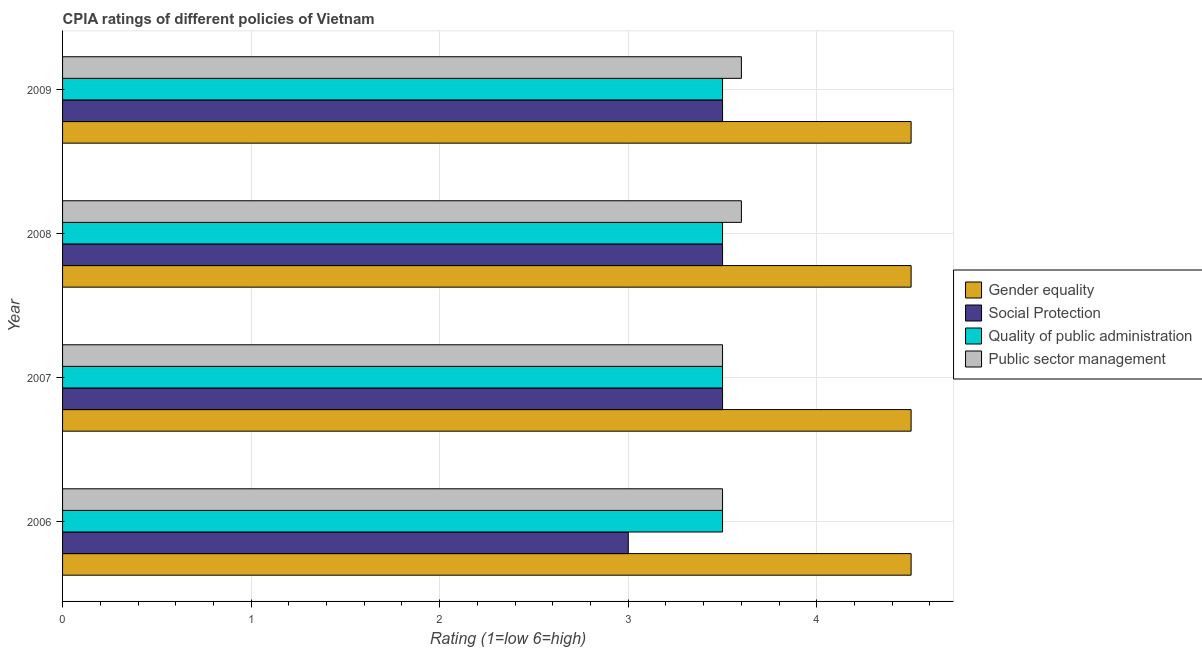Are the number of bars on each tick of the Y-axis equal?
Your answer should be very brief. Yes. How many bars are there on the 2nd tick from the top?
Make the answer very short. 4. What is the label of the 4th group of bars from the top?
Keep it short and to the point. 2006. In how many cases, is the number of bars for a given year not equal to the number of legend labels?
Your response must be concise. 0. Across all years, what is the maximum cpia rating of gender equality?
Offer a terse response. 4.5. Across all years, what is the minimum cpia rating of public sector management?
Your response must be concise. 3.5. What is the difference between the cpia rating of gender equality in 2006 and the cpia rating of public sector management in 2008?
Provide a succinct answer. 0.9. What is the average cpia rating of gender equality per year?
Offer a terse response. 4.5. What is the ratio of the cpia rating of social protection in 2006 to that in 2008?
Provide a succinct answer. 0.86. Is the difference between the cpia rating of public sector management in 2006 and 2009 greater than the difference between the cpia rating of social protection in 2006 and 2009?
Give a very brief answer. Yes. In how many years, is the cpia rating of social protection greater than the average cpia rating of social protection taken over all years?
Provide a short and direct response. 3. Is it the case that in every year, the sum of the cpia rating of social protection and cpia rating of quality of public administration is greater than the sum of cpia rating of gender equality and cpia rating of public sector management?
Provide a succinct answer. No. What does the 1st bar from the top in 2007 represents?
Give a very brief answer. Public sector management. What does the 2nd bar from the bottom in 2006 represents?
Your answer should be very brief. Social Protection. How many bars are there?
Ensure brevity in your answer.  16. Are all the bars in the graph horizontal?
Provide a short and direct response. Yes. Where does the legend appear in the graph?
Your answer should be very brief. Center right. How are the legend labels stacked?
Offer a terse response. Vertical. What is the title of the graph?
Ensure brevity in your answer.  CPIA ratings of different policies of Vietnam. What is the label or title of the X-axis?
Your response must be concise. Rating (1=low 6=high). What is the Rating (1=low 6=high) in Social Protection in 2006?
Provide a short and direct response. 3. What is the Rating (1=low 6=high) of Quality of public administration in 2006?
Keep it short and to the point. 3.5. What is the Rating (1=low 6=high) of Gender equality in 2007?
Your answer should be very brief. 4.5. What is the Rating (1=low 6=high) in Public sector management in 2007?
Give a very brief answer. 3.5. What is the Rating (1=low 6=high) of Gender equality in 2008?
Give a very brief answer. 4.5. What is the Rating (1=low 6=high) of Quality of public administration in 2008?
Provide a succinct answer. 3.5. What is the Rating (1=low 6=high) of Gender equality in 2009?
Your answer should be very brief. 4.5. What is the Rating (1=low 6=high) of Public sector management in 2009?
Keep it short and to the point. 3.6. Across all years, what is the maximum Rating (1=low 6=high) in Public sector management?
Offer a very short reply. 3.6. Across all years, what is the minimum Rating (1=low 6=high) in Social Protection?
Give a very brief answer. 3. Across all years, what is the minimum Rating (1=low 6=high) in Quality of public administration?
Offer a terse response. 3.5. What is the total Rating (1=low 6=high) in Quality of public administration in the graph?
Offer a terse response. 14. What is the total Rating (1=low 6=high) of Public sector management in the graph?
Your answer should be very brief. 14.2. What is the difference between the Rating (1=low 6=high) in Gender equality in 2006 and that in 2007?
Make the answer very short. 0. What is the difference between the Rating (1=low 6=high) in Social Protection in 2006 and that in 2007?
Offer a terse response. -0.5. What is the difference between the Rating (1=low 6=high) in Public sector management in 2006 and that in 2007?
Offer a very short reply. 0. What is the difference between the Rating (1=low 6=high) in Gender equality in 2006 and that in 2008?
Offer a terse response. 0. What is the difference between the Rating (1=low 6=high) of Social Protection in 2006 and that in 2008?
Your answer should be very brief. -0.5. What is the difference between the Rating (1=low 6=high) of Quality of public administration in 2006 and that in 2008?
Make the answer very short. 0. What is the difference between the Rating (1=low 6=high) of Social Protection in 2006 and that in 2009?
Offer a very short reply. -0.5. What is the difference between the Rating (1=low 6=high) in Public sector management in 2006 and that in 2009?
Your answer should be compact. -0.1. What is the difference between the Rating (1=low 6=high) in Gender equality in 2007 and that in 2008?
Your answer should be very brief. 0. What is the difference between the Rating (1=low 6=high) of Social Protection in 2007 and that in 2008?
Ensure brevity in your answer.  0. What is the difference between the Rating (1=low 6=high) of Social Protection in 2007 and that in 2009?
Offer a very short reply. 0. What is the difference between the Rating (1=low 6=high) of Public sector management in 2007 and that in 2009?
Make the answer very short. -0.1. What is the difference between the Rating (1=low 6=high) in Public sector management in 2008 and that in 2009?
Provide a succinct answer. 0. What is the difference between the Rating (1=low 6=high) of Social Protection in 2006 and the Rating (1=low 6=high) of Public sector management in 2007?
Offer a terse response. -0.5. What is the difference between the Rating (1=low 6=high) in Quality of public administration in 2006 and the Rating (1=low 6=high) in Public sector management in 2007?
Provide a short and direct response. 0. What is the difference between the Rating (1=low 6=high) of Gender equality in 2006 and the Rating (1=low 6=high) of Social Protection in 2008?
Offer a very short reply. 1. What is the difference between the Rating (1=low 6=high) in Quality of public administration in 2006 and the Rating (1=low 6=high) in Public sector management in 2008?
Ensure brevity in your answer.  -0.1. What is the difference between the Rating (1=low 6=high) in Gender equality in 2006 and the Rating (1=low 6=high) in Social Protection in 2009?
Keep it short and to the point. 1. What is the difference between the Rating (1=low 6=high) of Gender equality in 2006 and the Rating (1=low 6=high) of Quality of public administration in 2009?
Offer a terse response. 1. What is the difference between the Rating (1=low 6=high) in Gender equality in 2006 and the Rating (1=low 6=high) in Public sector management in 2009?
Offer a very short reply. 0.9. What is the difference between the Rating (1=low 6=high) in Social Protection in 2006 and the Rating (1=low 6=high) in Quality of public administration in 2009?
Your response must be concise. -0.5. What is the difference between the Rating (1=low 6=high) in Gender equality in 2007 and the Rating (1=low 6=high) in Social Protection in 2008?
Your answer should be very brief. 1. What is the difference between the Rating (1=low 6=high) of Gender equality in 2007 and the Rating (1=low 6=high) of Quality of public administration in 2008?
Offer a terse response. 1. What is the difference between the Rating (1=low 6=high) of Gender equality in 2007 and the Rating (1=low 6=high) of Public sector management in 2008?
Keep it short and to the point. 0.9. What is the difference between the Rating (1=low 6=high) in Gender equality in 2007 and the Rating (1=low 6=high) in Public sector management in 2009?
Offer a very short reply. 0.9. What is the difference between the Rating (1=low 6=high) of Social Protection in 2007 and the Rating (1=low 6=high) of Quality of public administration in 2009?
Offer a very short reply. 0. What is the difference between the Rating (1=low 6=high) of Social Protection in 2007 and the Rating (1=low 6=high) of Public sector management in 2009?
Your answer should be compact. -0.1. What is the difference between the Rating (1=low 6=high) in Quality of public administration in 2007 and the Rating (1=low 6=high) in Public sector management in 2009?
Your answer should be compact. -0.1. What is the difference between the Rating (1=low 6=high) of Gender equality in 2008 and the Rating (1=low 6=high) of Social Protection in 2009?
Provide a short and direct response. 1. What is the difference between the Rating (1=low 6=high) of Gender equality in 2008 and the Rating (1=low 6=high) of Quality of public administration in 2009?
Offer a very short reply. 1. What is the average Rating (1=low 6=high) in Gender equality per year?
Give a very brief answer. 4.5. What is the average Rating (1=low 6=high) in Social Protection per year?
Keep it short and to the point. 3.38. What is the average Rating (1=low 6=high) in Quality of public administration per year?
Keep it short and to the point. 3.5. What is the average Rating (1=low 6=high) in Public sector management per year?
Make the answer very short. 3.55. In the year 2006, what is the difference between the Rating (1=low 6=high) of Gender equality and Rating (1=low 6=high) of Public sector management?
Your answer should be very brief. 1. In the year 2006, what is the difference between the Rating (1=low 6=high) of Social Protection and Rating (1=low 6=high) of Quality of public administration?
Offer a very short reply. -0.5. In the year 2006, what is the difference between the Rating (1=low 6=high) in Social Protection and Rating (1=low 6=high) in Public sector management?
Your response must be concise. -0.5. In the year 2007, what is the difference between the Rating (1=low 6=high) of Gender equality and Rating (1=low 6=high) of Social Protection?
Your answer should be compact. 1. In the year 2007, what is the difference between the Rating (1=low 6=high) in Gender equality and Rating (1=low 6=high) in Quality of public administration?
Provide a succinct answer. 1. In the year 2007, what is the difference between the Rating (1=low 6=high) in Gender equality and Rating (1=low 6=high) in Public sector management?
Give a very brief answer. 1. In the year 2007, what is the difference between the Rating (1=low 6=high) of Social Protection and Rating (1=low 6=high) of Public sector management?
Offer a very short reply. 0. In the year 2008, what is the difference between the Rating (1=low 6=high) of Gender equality and Rating (1=low 6=high) of Quality of public administration?
Provide a short and direct response. 1. In the year 2008, what is the difference between the Rating (1=low 6=high) of Social Protection and Rating (1=low 6=high) of Quality of public administration?
Make the answer very short. 0. In the year 2008, what is the difference between the Rating (1=low 6=high) of Quality of public administration and Rating (1=low 6=high) of Public sector management?
Keep it short and to the point. -0.1. In the year 2009, what is the difference between the Rating (1=low 6=high) of Gender equality and Rating (1=low 6=high) of Public sector management?
Provide a short and direct response. 0.9. In the year 2009, what is the difference between the Rating (1=low 6=high) of Social Protection and Rating (1=low 6=high) of Quality of public administration?
Make the answer very short. 0. In the year 2009, what is the difference between the Rating (1=low 6=high) of Quality of public administration and Rating (1=low 6=high) of Public sector management?
Ensure brevity in your answer.  -0.1. What is the ratio of the Rating (1=low 6=high) of Quality of public administration in 2006 to that in 2007?
Keep it short and to the point. 1. What is the ratio of the Rating (1=low 6=high) in Gender equality in 2006 to that in 2008?
Keep it short and to the point. 1. What is the ratio of the Rating (1=low 6=high) in Social Protection in 2006 to that in 2008?
Give a very brief answer. 0.86. What is the ratio of the Rating (1=low 6=high) in Public sector management in 2006 to that in 2008?
Make the answer very short. 0.97. What is the ratio of the Rating (1=low 6=high) in Social Protection in 2006 to that in 2009?
Give a very brief answer. 0.86. What is the ratio of the Rating (1=low 6=high) in Quality of public administration in 2006 to that in 2009?
Your response must be concise. 1. What is the ratio of the Rating (1=low 6=high) in Public sector management in 2006 to that in 2009?
Make the answer very short. 0.97. What is the ratio of the Rating (1=low 6=high) of Gender equality in 2007 to that in 2008?
Provide a short and direct response. 1. What is the ratio of the Rating (1=low 6=high) in Social Protection in 2007 to that in 2008?
Give a very brief answer. 1. What is the ratio of the Rating (1=low 6=high) in Public sector management in 2007 to that in 2008?
Provide a succinct answer. 0.97. What is the ratio of the Rating (1=low 6=high) in Public sector management in 2007 to that in 2009?
Provide a short and direct response. 0.97. What is the ratio of the Rating (1=low 6=high) of Social Protection in 2008 to that in 2009?
Offer a very short reply. 1. What is the ratio of the Rating (1=low 6=high) in Quality of public administration in 2008 to that in 2009?
Offer a terse response. 1. What is the difference between the highest and the second highest Rating (1=low 6=high) of Quality of public administration?
Ensure brevity in your answer.  0. What is the difference between the highest and the lowest Rating (1=low 6=high) in Gender equality?
Offer a terse response. 0. What is the difference between the highest and the lowest Rating (1=low 6=high) of Public sector management?
Provide a succinct answer. 0.1. 